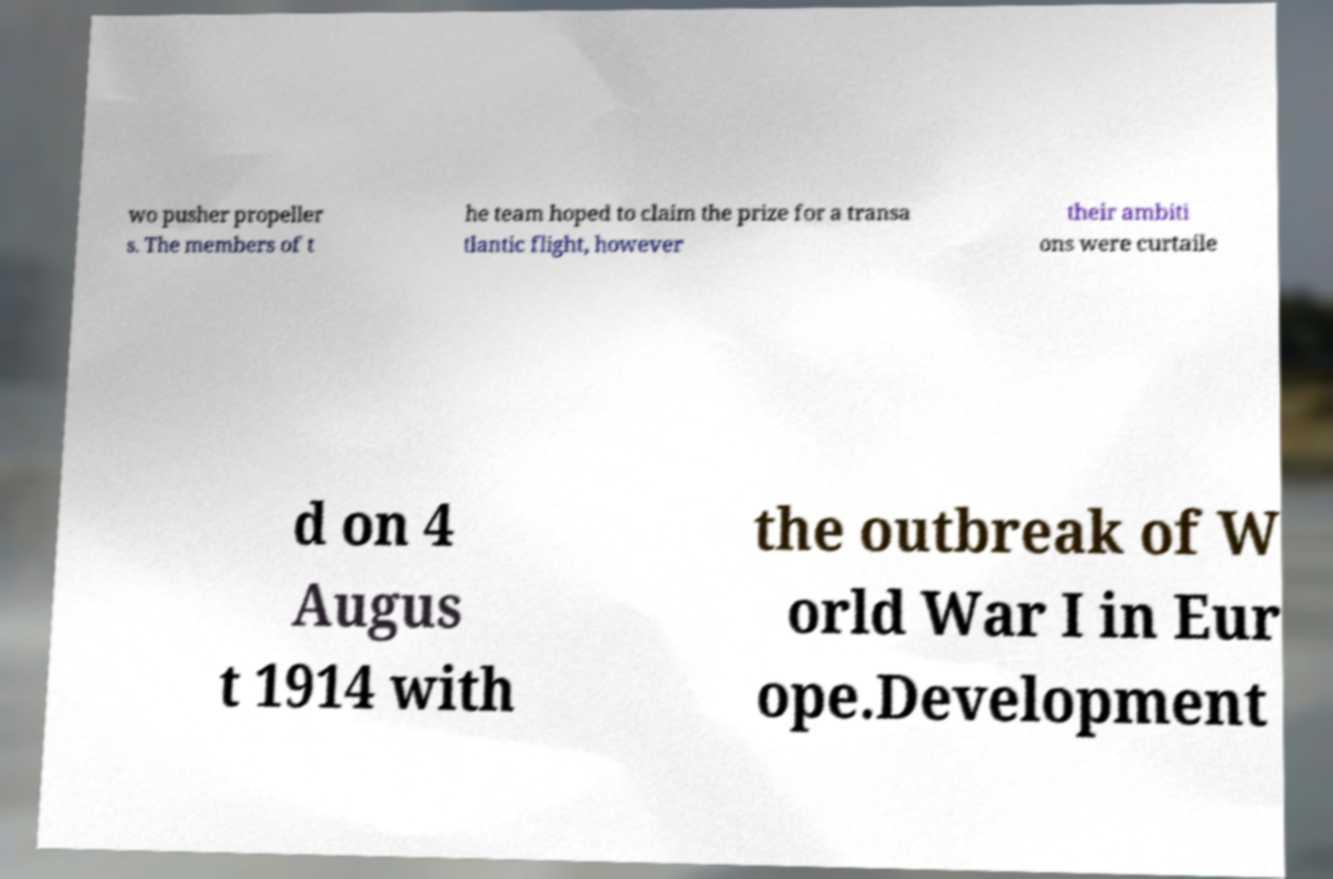There's text embedded in this image that I need extracted. Can you transcribe it verbatim? wo pusher propeller s. The members of t he team hoped to claim the prize for a transa tlantic flight, however their ambiti ons were curtaile d on 4 Augus t 1914 with the outbreak of W orld War I in Eur ope.Development 